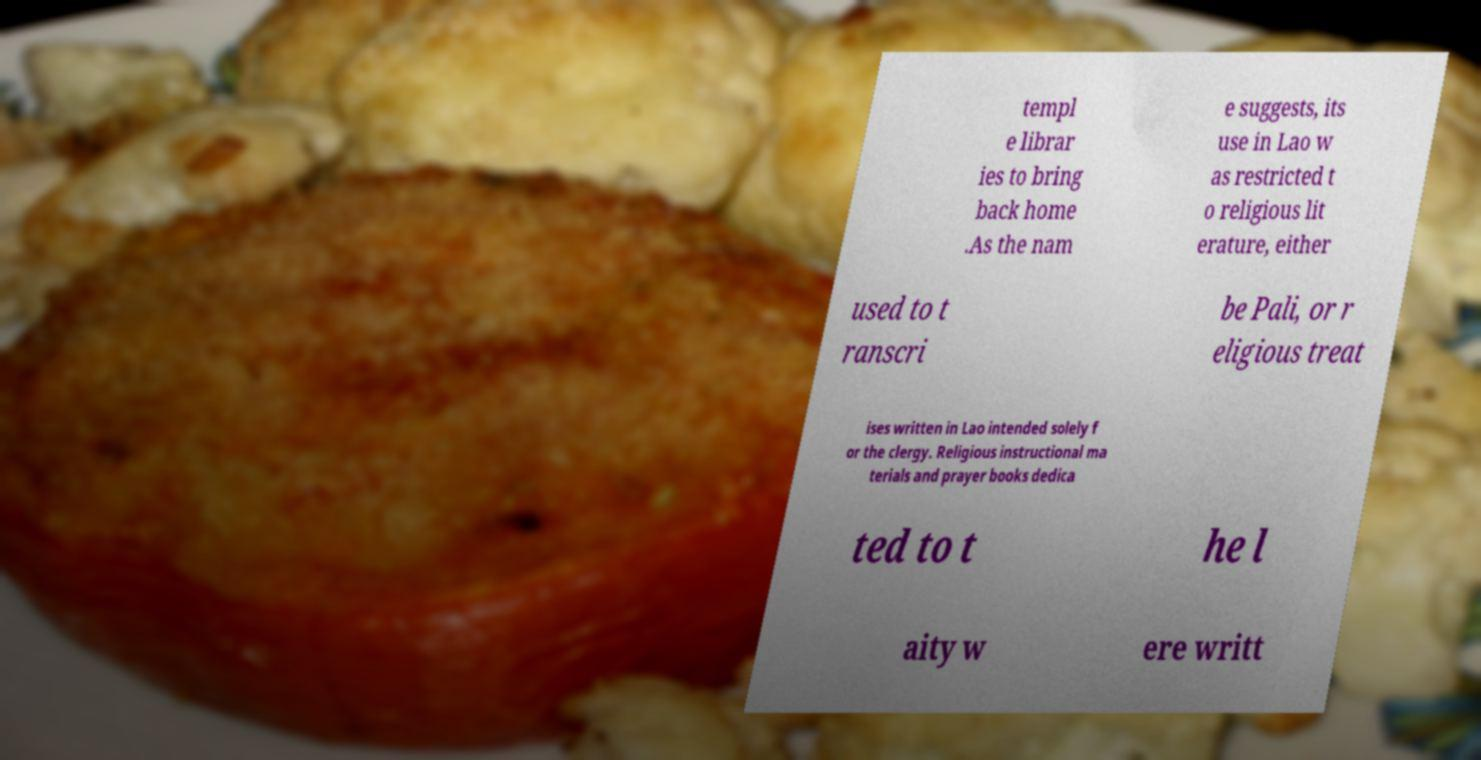Could you assist in decoding the text presented in this image and type it out clearly? templ e librar ies to bring back home .As the nam e suggests, its use in Lao w as restricted t o religious lit erature, either used to t ranscri be Pali, or r eligious treat ises written in Lao intended solely f or the clergy. Religious instructional ma terials and prayer books dedica ted to t he l aity w ere writt 